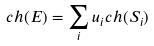Convert formula to latex. <formula><loc_0><loc_0><loc_500><loc_500>c h ( E ) = \sum _ { i } u _ { i } c h ( S _ { i } )</formula> 